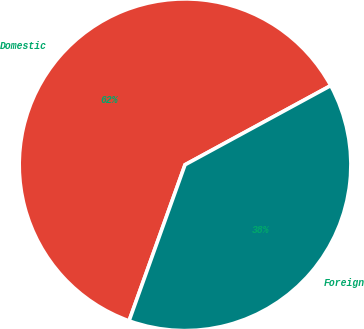Convert chart. <chart><loc_0><loc_0><loc_500><loc_500><pie_chart><fcel>Domestic<fcel>Foreign<nl><fcel>61.6%<fcel>38.4%<nl></chart> 